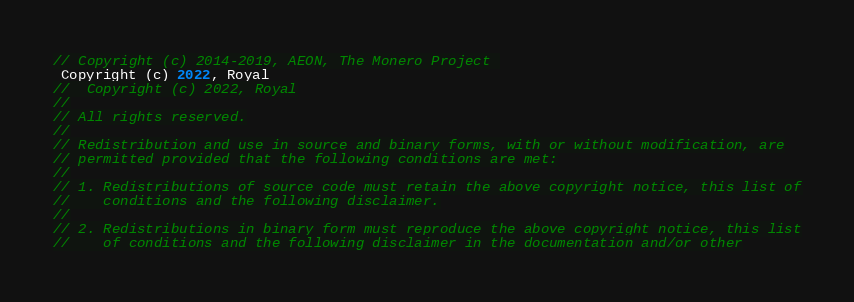Convert code to text. <code><loc_0><loc_0><loc_500><loc_500><_C++_>// Copyright (c) 2014-2019, AEON, The Monero Project 
 Copyright (c) 2022, Royal 
//  Copyright (c) 2022, Royal
//
// All rights reserved.
//
// Redistribution and use in source and binary forms, with or without modification, are
// permitted provided that the following conditions are met:
//
// 1. Redistributions of source code must retain the above copyright notice, this list of
//    conditions and the following disclaimer.
//
// 2. Redistributions in binary form must reproduce the above copyright notice, this list
//    of conditions and the following disclaimer in the documentation and/or other</code> 